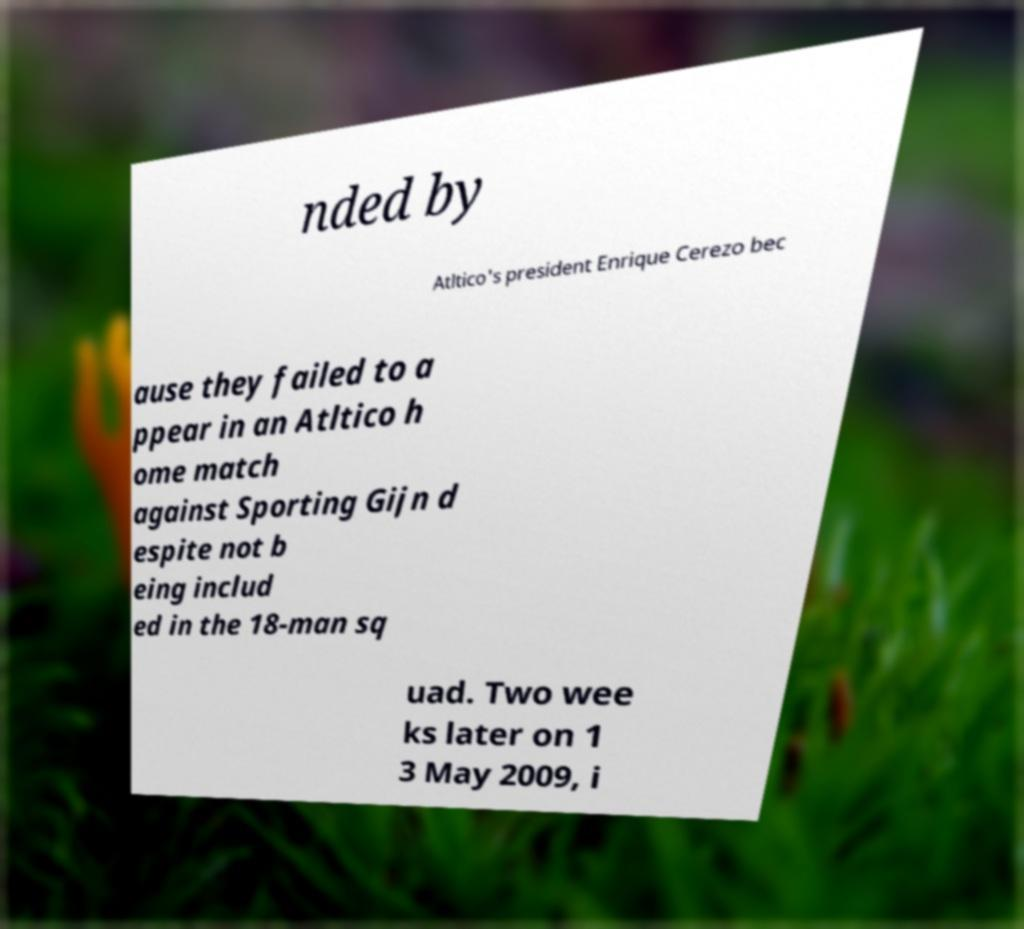Please read and relay the text visible in this image. What does it say? nded by Atltico's president Enrique Cerezo bec ause they failed to a ppear in an Atltico h ome match against Sporting Gijn d espite not b eing includ ed in the 18-man sq uad. Two wee ks later on 1 3 May 2009, i 